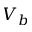<formula> <loc_0><loc_0><loc_500><loc_500>V _ { b }</formula> 